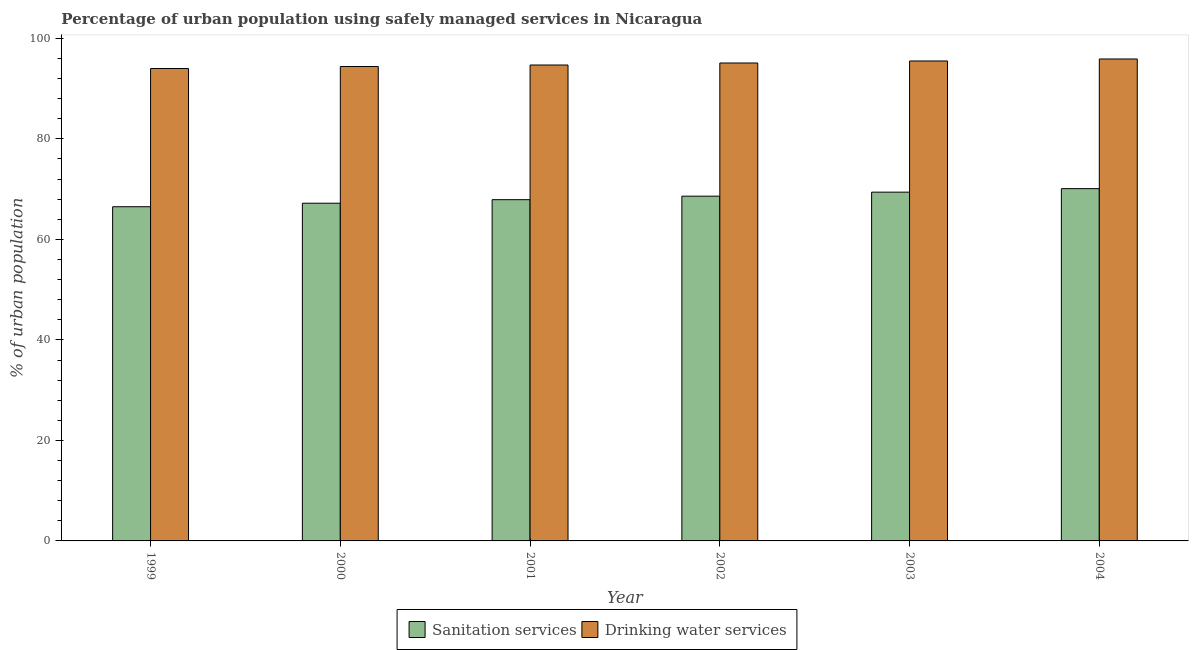How many groups of bars are there?
Make the answer very short. 6. Are the number of bars per tick equal to the number of legend labels?
Your response must be concise. Yes. How many bars are there on the 6th tick from the left?
Offer a terse response. 2. What is the label of the 3rd group of bars from the left?
Offer a very short reply. 2001. In how many cases, is the number of bars for a given year not equal to the number of legend labels?
Offer a very short reply. 0. What is the percentage of urban population who used sanitation services in 2001?
Provide a short and direct response. 67.9. Across all years, what is the maximum percentage of urban population who used drinking water services?
Your answer should be very brief. 95.9. Across all years, what is the minimum percentage of urban population who used sanitation services?
Offer a very short reply. 66.5. In which year was the percentage of urban population who used sanitation services maximum?
Make the answer very short. 2004. What is the total percentage of urban population who used drinking water services in the graph?
Offer a very short reply. 569.6. What is the difference between the percentage of urban population who used drinking water services in 2001 and that in 2002?
Your response must be concise. -0.4. What is the difference between the percentage of urban population who used sanitation services in 2004 and the percentage of urban population who used drinking water services in 2002?
Your answer should be compact. 1.5. What is the average percentage of urban population who used drinking water services per year?
Provide a short and direct response. 94.93. In the year 2003, what is the difference between the percentage of urban population who used sanitation services and percentage of urban population who used drinking water services?
Your response must be concise. 0. In how many years, is the percentage of urban population who used sanitation services greater than 72 %?
Your answer should be compact. 0. What is the ratio of the percentage of urban population who used sanitation services in 1999 to that in 2004?
Give a very brief answer. 0.95. Is the difference between the percentage of urban population who used sanitation services in 2001 and 2004 greater than the difference between the percentage of urban population who used drinking water services in 2001 and 2004?
Ensure brevity in your answer.  No. What is the difference between the highest and the second highest percentage of urban population who used drinking water services?
Give a very brief answer. 0.4. What is the difference between the highest and the lowest percentage of urban population who used drinking water services?
Your answer should be compact. 1.9. What does the 2nd bar from the left in 2002 represents?
Provide a succinct answer. Drinking water services. What does the 1st bar from the right in 2001 represents?
Offer a very short reply. Drinking water services. How many bars are there?
Give a very brief answer. 12. Are the values on the major ticks of Y-axis written in scientific E-notation?
Your answer should be compact. No. Where does the legend appear in the graph?
Keep it short and to the point. Bottom center. How are the legend labels stacked?
Your response must be concise. Horizontal. What is the title of the graph?
Give a very brief answer. Percentage of urban population using safely managed services in Nicaragua. Does "Secondary" appear as one of the legend labels in the graph?
Ensure brevity in your answer.  No. What is the label or title of the X-axis?
Keep it short and to the point. Year. What is the label or title of the Y-axis?
Your response must be concise. % of urban population. What is the % of urban population of Sanitation services in 1999?
Ensure brevity in your answer.  66.5. What is the % of urban population of Drinking water services in 1999?
Keep it short and to the point. 94. What is the % of urban population in Sanitation services in 2000?
Provide a short and direct response. 67.2. What is the % of urban population of Drinking water services in 2000?
Offer a terse response. 94.4. What is the % of urban population in Sanitation services in 2001?
Your answer should be very brief. 67.9. What is the % of urban population of Drinking water services in 2001?
Your response must be concise. 94.7. What is the % of urban population in Sanitation services in 2002?
Your response must be concise. 68.6. What is the % of urban population of Drinking water services in 2002?
Your answer should be compact. 95.1. What is the % of urban population in Sanitation services in 2003?
Provide a succinct answer. 69.4. What is the % of urban population in Drinking water services in 2003?
Provide a succinct answer. 95.5. What is the % of urban population of Sanitation services in 2004?
Ensure brevity in your answer.  70.1. What is the % of urban population of Drinking water services in 2004?
Keep it short and to the point. 95.9. Across all years, what is the maximum % of urban population in Sanitation services?
Ensure brevity in your answer.  70.1. Across all years, what is the maximum % of urban population in Drinking water services?
Your answer should be very brief. 95.9. Across all years, what is the minimum % of urban population of Sanitation services?
Your response must be concise. 66.5. Across all years, what is the minimum % of urban population in Drinking water services?
Give a very brief answer. 94. What is the total % of urban population of Sanitation services in the graph?
Keep it short and to the point. 409.7. What is the total % of urban population of Drinking water services in the graph?
Provide a succinct answer. 569.6. What is the difference between the % of urban population of Drinking water services in 1999 and that in 2000?
Provide a succinct answer. -0.4. What is the difference between the % of urban population of Drinking water services in 1999 and that in 2001?
Your answer should be very brief. -0.7. What is the difference between the % of urban population in Drinking water services in 1999 and that in 2002?
Provide a succinct answer. -1.1. What is the difference between the % of urban population of Drinking water services in 1999 and that in 2003?
Your response must be concise. -1.5. What is the difference between the % of urban population of Sanitation services in 1999 and that in 2004?
Ensure brevity in your answer.  -3.6. What is the difference between the % of urban population in Drinking water services in 1999 and that in 2004?
Provide a succinct answer. -1.9. What is the difference between the % of urban population in Sanitation services in 2000 and that in 2001?
Provide a succinct answer. -0.7. What is the difference between the % of urban population in Drinking water services in 2000 and that in 2002?
Your answer should be compact. -0.7. What is the difference between the % of urban population of Sanitation services in 2001 and that in 2002?
Give a very brief answer. -0.7. What is the difference between the % of urban population of Sanitation services in 2001 and that in 2003?
Offer a very short reply. -1.5. What is the difference between the % of urban population in Sanitation services in 2002 and that in 2003?
Provide a short and direct response. -0.8. What is the difference between the % of urban population of Drinking water services in 2002 and that in 2003?
Provide a short and direct response. -0.4. What is the difference between the % of urban population of Drinking water services in 2002 and that in 2004?
Your answer should be compact. -0.8. What is the difference between the % of urban population in Drinking water services in 2003 and that in 2004?
Provide a succinct answer. -0.4. What is the difference between the % of urban population of Sanitation services in 1999 and the % of urban population of Drinking water services in 2000?
Keep it short and to the point. -27.9. What is the difference between the % of urban population in Sanitation services in 1999 and the % of urban population in Drinking water services in 2001?
Offer a terse response. -28.2. What is the difference between the % of urban population of Sanitation services in 1999 and the % of urban population of Drinking water services in 2002?
Keep it short and to the point. -28.6. What is the difference between the % of urban population in Sanitation services in 1999 and the % of urban population in Drinking water services in 2003?
Your answer should be very brief. -29. What is the difference between the % of urban population in Sanitation services in 1999 and the % of urban population in Drinking water services in 2004?
Provide a succinct answer. -29.4. What is the difference between the % of urban population in Sanitation services in 2000 and the % of urban population in Drinking water services in 2001?
Provide a succinct answer. -27.5. What is the difference between the % of urban population of Sanitation services in 2000 and the % of urban population of Drinking water services in 2002?
Your answer should be very brief. -27.9. What is the difference between the % of urban population of Sanitation services in 2000 and the % of urban population of Drinking water services in 2003?
Keep it short and to the point. -28.3. What is the difference between the % of urban population in Sanitation services in 2000 and the % of urban population in Drinking water services in 2004?
Provide a short and direct response. -28.7. What is the difference between the % of urban population of Sanitation services in 2001 and the % of urban population of Drinking water services in 2002?
Your answer should be compact. -27.2. What is the difference between the % of urban population in Sanitation services in 2001 and the % of urban population in Drinking water services in 2003?
Keep it short and to the point. -27.6. What is the difference between the % of urban population of Sanitation services in 2001 and the % of urban population of Drinking water services in 2004?
Give a very brief answer. -28. What is the difference between the % of urban population of Sanitation services in 2002 and the % of urban population of Drinking water services in 2003?
Provide a short and direct response. -26.9. What is the difference between the % of urban population of Sanitation services in 2002 and the % of urban population of Drinking water services in 2004?
Your answer should be very brief. -27.3. What is the difference between the % of urban population in Sanitation services in 2003 and the % of urban population in Drinking water services in 2004?
Ensure brevity in your answer.  -26.5. What is the average % of urban population in Sanitation services per year?
Keep it short and to the point. 68.28. What is the average % of urban population of Drinking water services per year?
Offer a terse response. 94.93. In the year 1999, what is the difference between the % of urban population in Sanitation services and % of urban population in Drinking water services?
Your answer should be compact. -27.5. In the year 2000, what is the difference between the % of urban population in Sanitation services and % of urban population in Drinking water services?
Make the answer very short. -27.2. In the year 2001, what is the difference between the % of urban population in Sanitation services and % of urban population in Drinking water services?
Your response must be concise. -26.8. In the year 2002, what is the difference between the % of urban population of Sanitation services and % of urban population of Drinking water services?
Make the answer very short. -26.5. In the year 2003, what is the difference between the % of urban population in Sanitation services and % of urban population in Drinking water services?
Offer a terse response. -26.1. In the year 2004, what is the difference between the % of urban population in Sanitation services and % of urban population in Drinking water services?
Ensure brevity in your answer.  -25.8. What is the ratio of the % of urban population in Sanitation services in 1999 to that in 2000?
Offer a very short reply. 0.99. What is the ratio of the % of urban population of Sanitation services in 1999 to that in 2001?
Your answer should be very brief. 0.98. What is the ratio of the % of urban population in Drinking water services in 1999 to that in 2001?
Your answer should be compact. 0.99. What is the ratio of the % of urban population of Sanitation services in 1999 to that in 2002?
Keep it short and to the point. 0.97. What is the ratio of the % of urban population in Drinking water services in 1999 to that in 2002?
Keep it short and to the point. 0.99. What is the ratio of the % of urban population in Sanitation services in 1999 to that in 2003?
Make the answer very short. 0.96. What is the ratio of the % of urban population in Drinking water services in 1999 to that in 2003?
Offer a very short reply. 0.98. What is the ratio of the % of urban population of Sanitation services in 1999 to that in 2004?
Provide a succinct answer. 0.95. What is the ratio of the % of urban population in Drinking water services in 1999 to that in 2004?
Offer a terse response. 0.98. What is the ratio of the % of urban population in Sanitation services in 2000 to that in 2001?
Give a very brief answer. 0.99. What is the ratio of the % of urban population of Drinking water services in 2000 to that in 2001?
Your response must be concise. 1. What is the ratio of the % of urban population of Sanitation services in 2000 to that in 2002?
Offer a terse response. 0.98. What is the ratio of the % of urban population of Sanitation services in 2000 to that in 2003?
Offer a very short reply. 0.97. What is the ratio of the % of urban population of Drinking water services in 2000 to that in 2003?
Provide a succinct answer. 0.99. What is the ratio of the % of urban population in Sanitation services in 2000 to that in 2004?
Your answer should be compact. 0.96. What is the ratio of the % of urban population in Drinking water services in 2000 to that in 2004?
Provide a succinct answer. 0.98. What is the ratio of the % of urban population of Sanitation services in 2001 to that in 2003?
Offer a very short reply. 0.98. What is the ratio of the % of urban population of Drinking water services in 2001 to that in 2003?
Your answer should be compact. 0.99. What is the ratio of the % of urban population in Sanitation services in 2001 to that in 2004?
Provide a succinct answer. 0.97. What is the ratio of the % of urban population in Drinking water services in 2001 to that in 2004?
Offer a terse response. 0.99. What is the ratio of the % of urban population of Sanitation services in 2002 to that in 2004?
Your answer should be very brief. 0.98. What is the ratio of the % of urban population of Drinking water services in 2002 to that in 2004?
Provide a short and direct response. 0.99. What is the ratio of the % of urban population in Drinking water services in 2003 to that in 2004?
Give a very brief answer. 1. What is the difference between the highest and the second highest % of urban population in Sanitation services?
Offer a very short reply. 0.7. What is the difference between the highest and the second highest % of urban population in Drinking water services?
Make the answer very short. 0.4. What is the difference between the highest and the lowest % of urban population of Sanitation services?
Give a very brief answer. 3.6. 